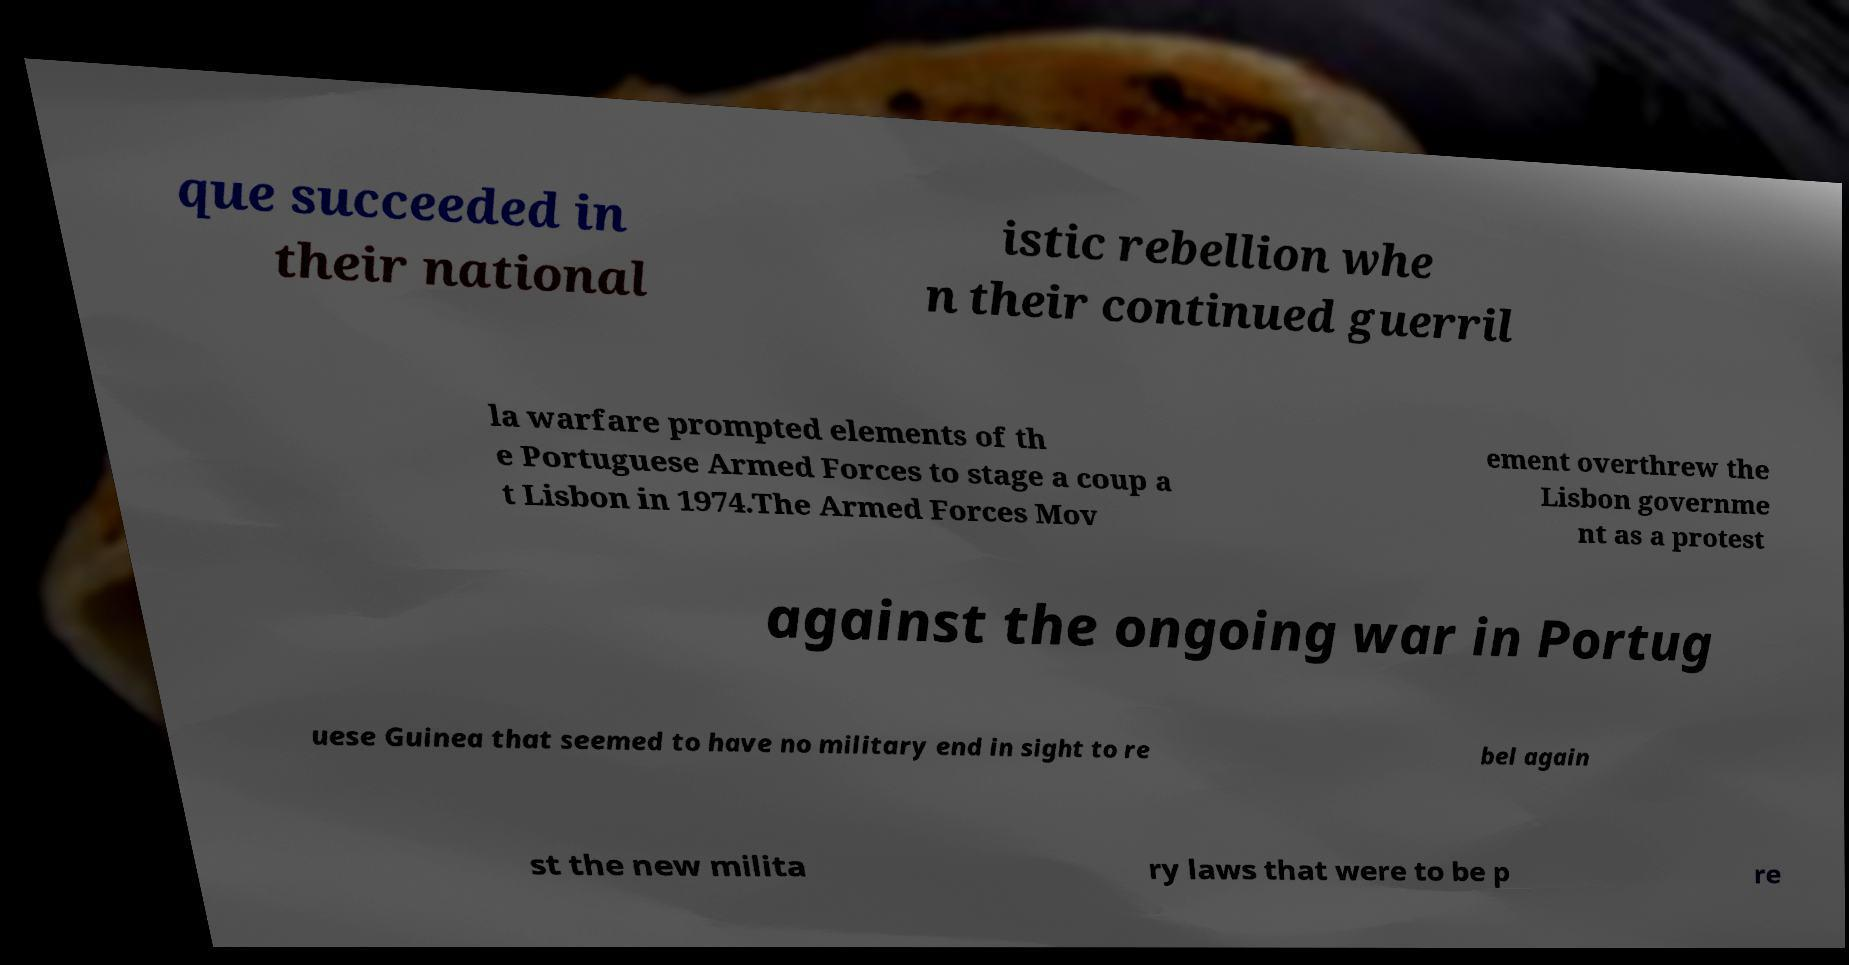What messages or text are displayed in this image? I need them in a readable, typed format. que succeeded in their national istic rebellion whe n their continued guerril la warfare prompted elements of th e Portuguese Armed Forces to stage a coup a t Lisbon in 1974.The Armed Forces Mov ement overthrew the Lisbon governme nt as a protest against the ongoing war in Portug uese Guinea that seemed to have no military end in sight to re bel again st the new milita ry laws that were to be p re 